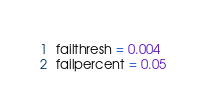<code> <loc_0><loc_0><loc_500><loc_500><_Python_>failthresh = 0.004
failpercent = 0.05
</code> 